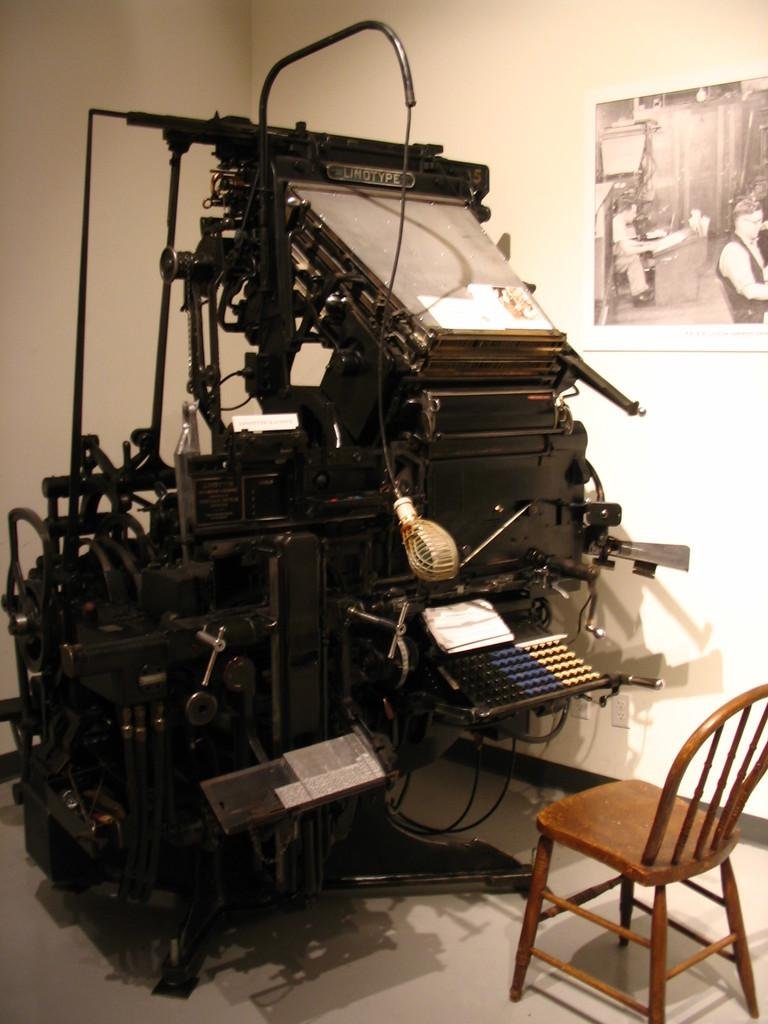What is the main object in the image? There is a machine in the image. What color is the machine? The machine is black in color. What type of furniture is present in the image? There is a brown color chair in the image. What can be seen on the wall in the background of the image? There is a frame on the wall in the background of the image. How does the machine aid in the digestion process in the image? The image does not show any digestion process or provide information about the machine's function, so it cannot be determined from the image. 